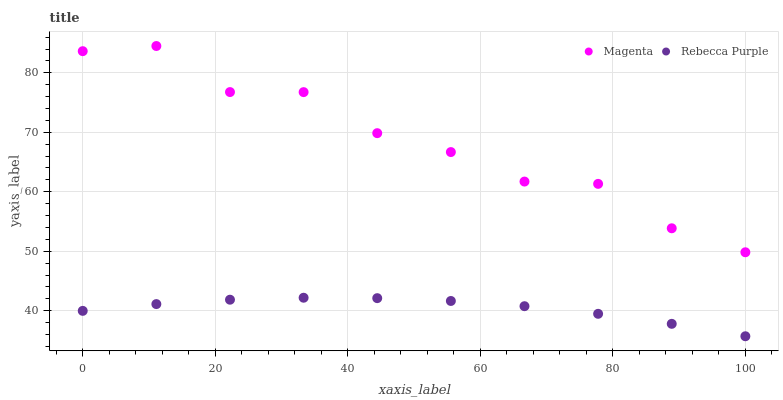Does Rebecca Purple have the minimum area under the curve?
Answer yes or no. Yes. Does Magenta have the maximum area under the curve?
Answer yes or no. Yes. Does Rebecca Purple have the maximum area under the curve?
Answer yes or no. No. Is Rebecca Purple the smoothest?
Answer yes or no. Yes. Is Magenta the roughest?
Answer yes or no. Yes. Is Rebecca Purple the roughest?
Answer yes or no. No. Does Rebecca Purple have the lowest value?
Answer yes or no. Yes. Does Magenta have the highest value?
Answer yes or no. Yes. Does Rebecca Purple have the highest value?
Answer yes or no. No. Is Rebecca Purple less than Magenta?
Answer yes or no. Yes. Is Magenta greater than Rebecca Purple?
Answer yes or no. Yes. Does Rebecca Purple intersect Magenta?
Answer yes or no. No. 